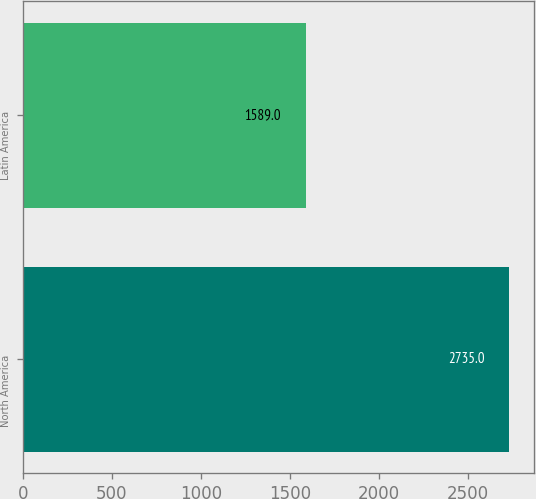<chart> <loc_0><loc_0><loc_500><loc_500><bar_chart><fcel>North America<fcel>Latin America<nl><fcel>2735<fcel>1589<nl></chart> 